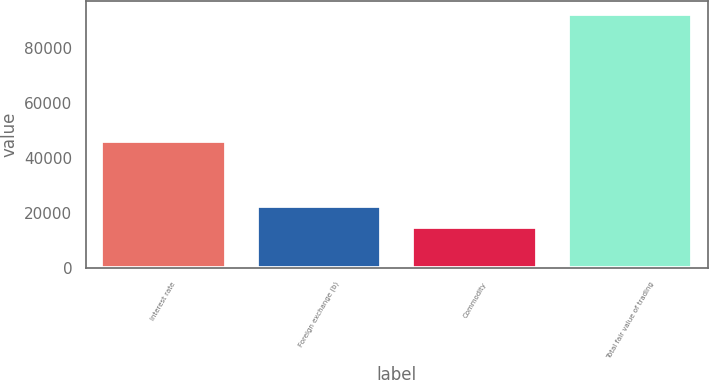Convert chart to OTSL. <chart><loc_0><loc_0><loc_500><loc_500><bar_chart><fcel>Interest rate<fcel>Foreign exchange (b)<fcel>Commodity<fcel>Total fair value of trading<nl><fcel>46369<fcel>22514.6<fcel>14741<fcel>92477<nl></chart> 